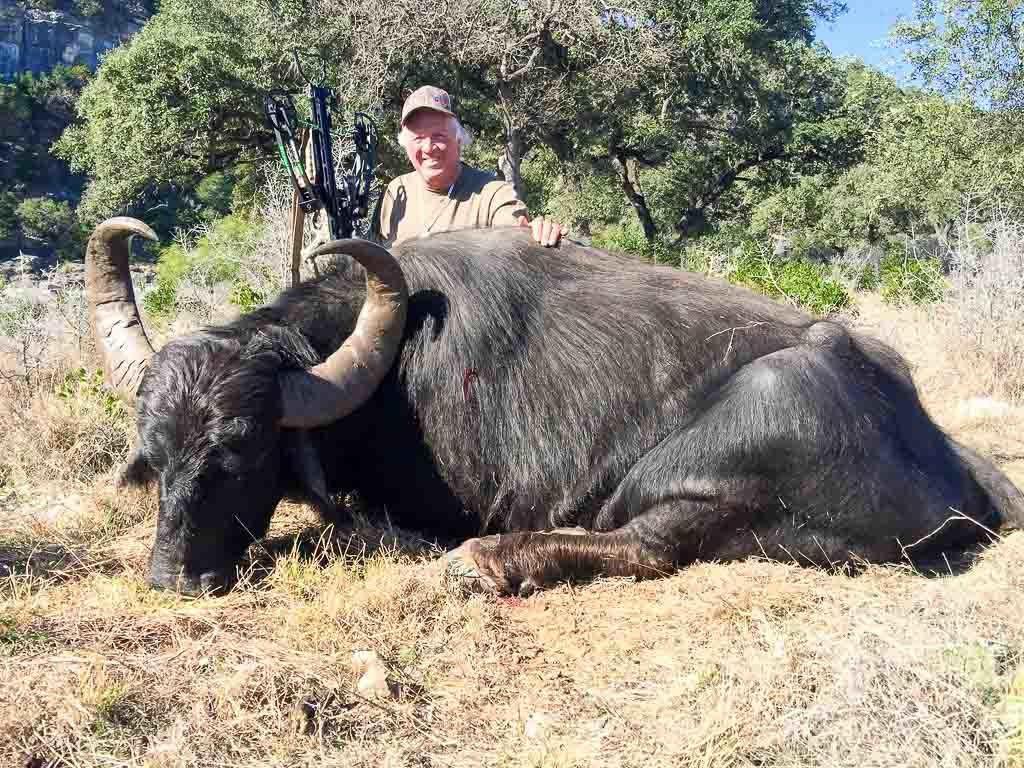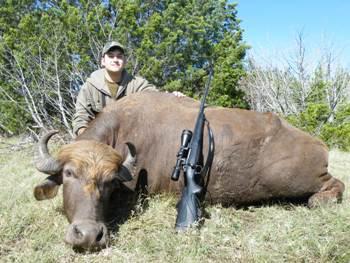The first image is the image on the left, the second image is the image on the right. For the images shown, is this caption "The left and right image contains the same number of dead bulls." true? Answer yes or no. Yes. The first image is the image on the left, the second image is the image on the right. For the images displayed, is the sentence "An animal is standing." factually correct? Answer yes or no. No. 